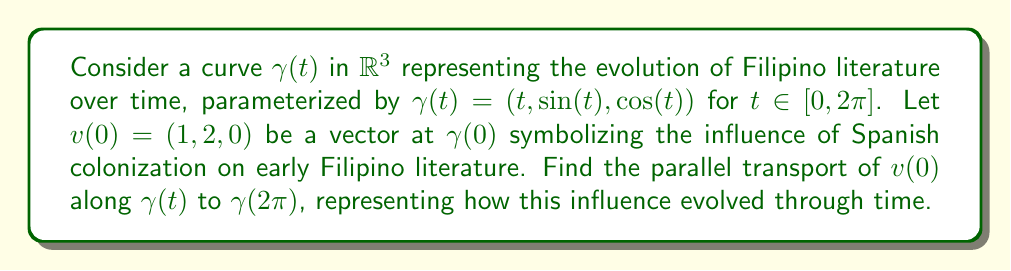Show me your answer to this math problem. To solve this problem, we'll follow these steps:

1) First, we need to calculate the tangent vector $T(t)$ to the curve:
   $$T(t) = \gamma'(t) = (1, \cos(t), -\sin(t))$$

2) Next, we compute the covariant derivative of the tangent vector:
   $$\frac{DT}{dt} = T'(t) = (0, -\sin(t), -\cos(t))$$

3) The parallel transport equation is given by:
   $$\frac{Dv}{dt} = 0$$
   This means that the covariant derivative of $v$ along $\gamma$ should be zero.

4) We can express this as:
   $$\frac{dv}{dt} + \Gamma v = 0$$
   where $\Gamma$ is the connection coefficient matrix.

5) In this case, $\Gamma$ can be calculated as:
   $$\Gamma = \frac{T \otimes \frac{DT}{dt}}{T \cdot T}$$

6) Substituting the values:
   $$\Gamma = \frac{(1, \cos(t), -\sin(t)) \otimes (0, -\sin(t), -\cos(t))}{1 + \cos^2(t) + \sin^2(t)} = \frac{1}{2}(0, -\sin(t), -\cos(t)) \otimes (1, \cos(t), -\sin(t))$$

7) The parallel transport equation becomes:
   $$\frac{dv}{dt} + \frac{1}{2}(0, -\sin(t), -\cos(t))(v \cdot (1, \cos(t), -\sin(t))) = 0$$

8) Solving this differential equation with the initial condition $v(0) = (1, 2, 0)$, we get:
   $$v(t) = (1, 2\cos(t), -2\sin(t))$$

9) Therefore, at $t = 2\pi$:
   $$v(2\pi) = (1, 2\cos(2\pi), -2\sin(2\pi)) = (1, 2, 0)$$

This result shows that the parallel transport of the vector returns to its original state after a complete revolution, symbolizing the cyclical nature of literary influences in Filipino literature.
Answer: $v(2\pi) = (1, 2, 0)$ 